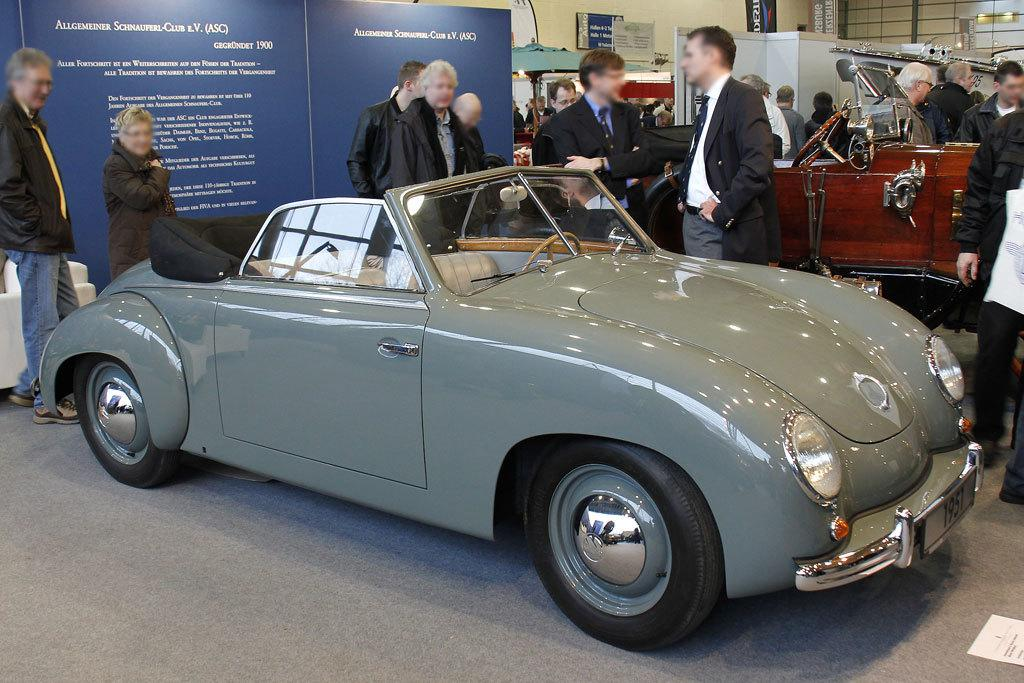Who or what can be seen in the image? There are people in the image. What else is present on the floor in the image? There are vehicles on the floor in the image. Are there any signs or messages visible in the image? Yes, there are boards with text in the image. What can be seen in the background of the image? There are objects in the background of the image. What type of vase is being used to express a reaction in the image? There is no vase present in the image, nor is there any indication of a reaction being expressed. 